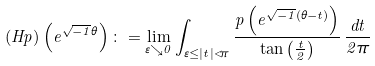<formula> <loc_0><loc_0><loc_500><loc_500>( H p ) \left ( e ^ { \sqrt { - 1 } \theta } \right ) \colon = \lim _ { \varepsilon \searrow 0 } \int _ { \varepsilon \leq | t | < \pi } \frac { p \left ( e ^ { \sqrt { - 1 } ( \theta - t ) } \right ) } { \tan \left ( \frac { t } { 2 } \right ) } \, \frac { d t } { 2 \pi }</formula> 